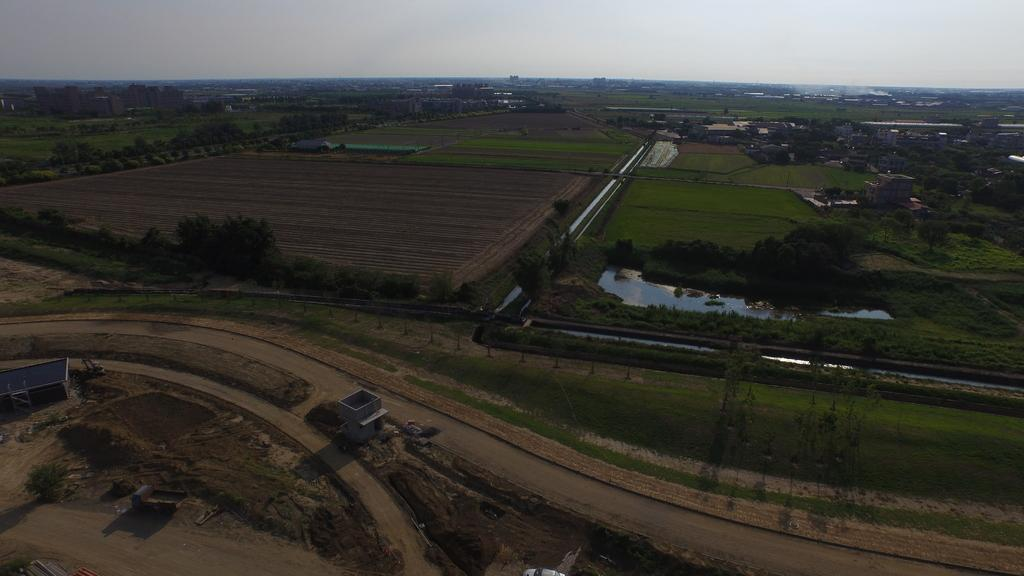What type of vegetation can be seen in the image? There is grass in the image. What other natural elements are present in the image? There are trees in the image. What man-made structures can be seen in the image? There are buildings in the image. What type of infrastructure is visible in the image? There are roads in the image. What body of water is visible in the image? There is water visible in the image. What is the source of the smoke in the image? The source of the smoke is not specified in the image. What can be seen in the background of the image? The sky is visible in the background of the image. How many snails are crawling on the heart in the image? There is no heart or snails present in the image. What advice is given by the person in the image? There is no person or advice present in the image. 